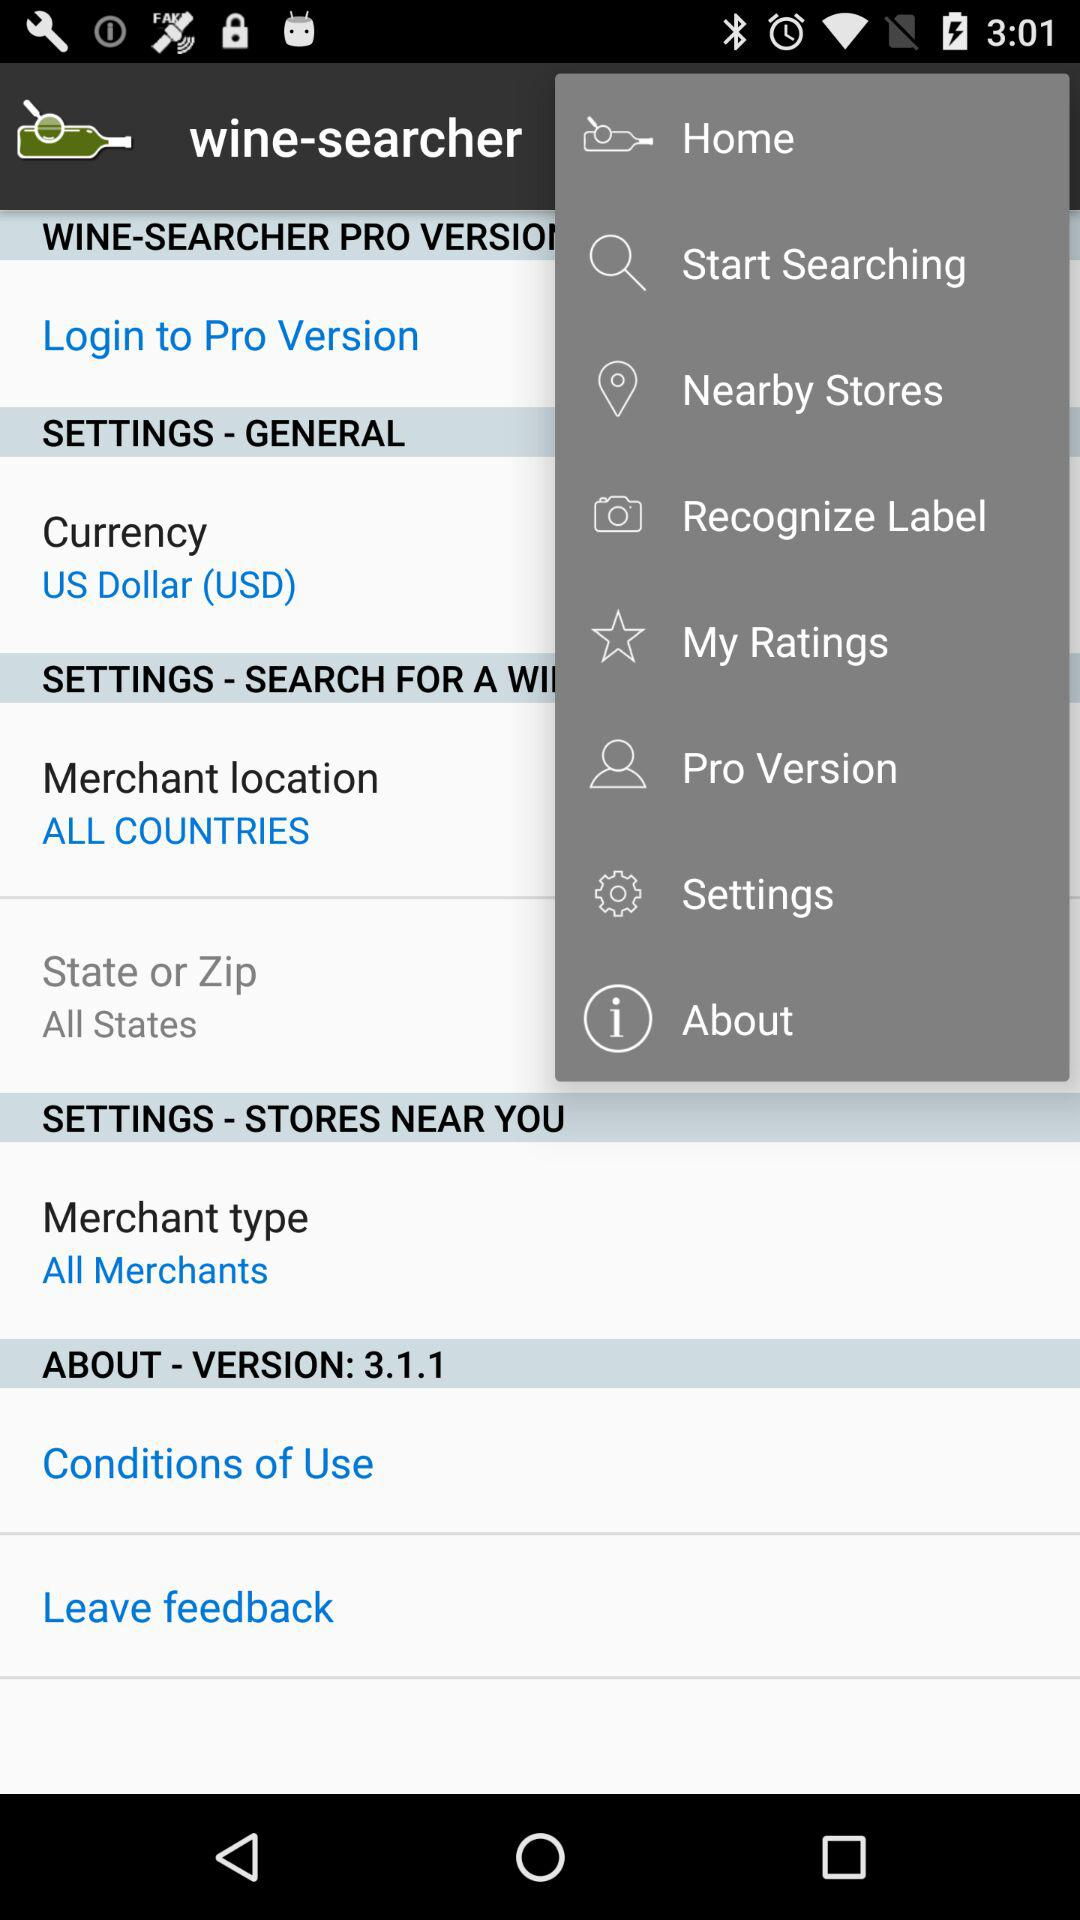What is the version? The version is 3.1.1. 